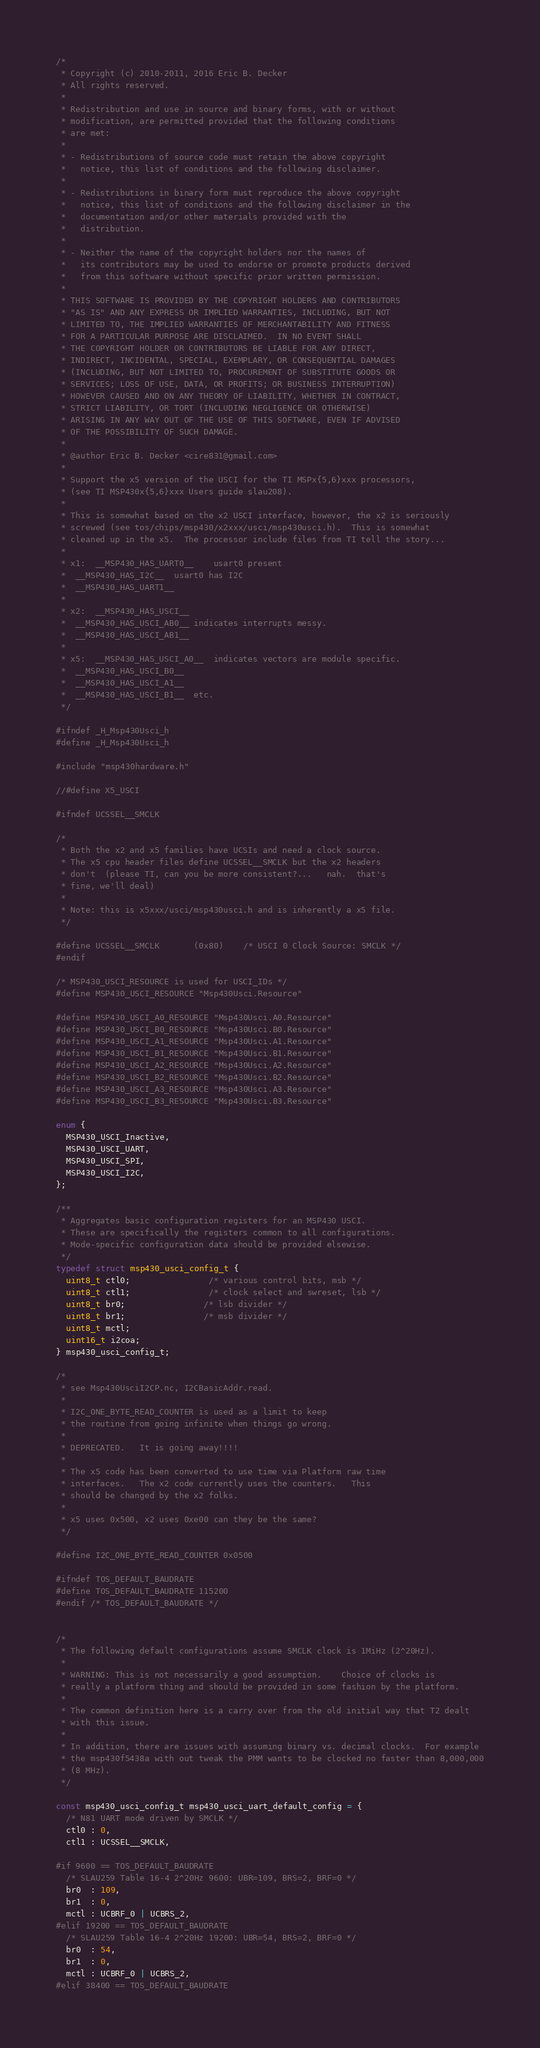<code> <loc_0><loc_0><loc_500><loc_500><_C_>/*
 * Copyright (c) 2010-2011, 2016 Eric B. Decker
 * All rights reserved.
 *
 * Redistribution and use in source and binary forms, with or without
 * modification, are permitted provided that the following conditions
 * are met:
 *
 * - Redistributions of source code must retain the above copyright
 *   notice, this list of conditions and the following disclaimer.
 *
 * - Redistributions in binary form must reproduce the above copyright
 *   notice, this list of conditions and the following disclaimer in the
 *   documentation and/or other materials provided with the
 *   distribution.
 *
 * - Neither the name of the copyright holders nor the names of
 *   its contributors may be used to endorse or promote products derived
 *   from this software without specific prior written permission.
 *
 * THIS SOFTWARE IS PROVIDED BY THE COPYRIGHT HOLDERS AND CONTRIBUTORS
 * "AS IS" AND ANY EXPRESS OR IMPLIED WARRANTIES, INCLUDING, BUT NOT
 * LIMITED TO, THE IMPLIED WARRANTIES OF MERCHANTABILITY AND FITNESS
 * FOR A PARTICULAR PURPOSE ARE DISCLAIMED.  IN NO EVENT SHALL
 * THE COPYRIGHT HOLDER OR CONTRIBUTORS BE LIABLE FOR ANY DIRECT,
 * INDIRECT, INCIDENTAL, SPECIAL, EXEMPLARY, OR CONSEQUENTIAL DAMAGES
 * (INCLUDING, BUT NOT LIMITED TO, PROCUREMENT OF SUBSTITUTE GOODS OR
 * SERVICES; LOSS OF USE, DATA, OR PROFITS; OR BUSINESS INTERRUPTION)
 * HOWEVER CAUSED AND ON ANY THEORY OF LIABILITY, WHETHER IN CONTRACT,
 * STRICT LIABILITY, OR TORT (INCLUDING NEGLIGENCE OR OTHERWISE)
 * ARISING IN ANY WAY OUT OF THE USE OF THIS SOFTWARE, EVEN IF ADVISED
 * OF THE POSSIBILITY OF SUCH DAMAGE.
 *
 * @author Eric B. Decker <cire831@gmail.com>
 *
 * Support the x5 version of the USCI for the TI MSPx{5,6}xxx processors,
 * (see TI MSP430x{5,6}xxx Users guide slau208).
 *
 * This is somewhat based on the x2 USCI interface, however, the x2 is seriously
 * screwed (see tos/chips/msp430/x2xxx/usci/msp430usci.h).  This is somewhat
 * cleaned up in the x5.  The processor include files from TI tell the story...
 *
 * x1:  __MSP430_HAS_UART0__	usart0 present
 *	__MSP430_HAS_I2C__	usart0 has I2C
 *	__MSP430_HAS_UART1__
 *
 * x2:	__MSP430_HAS_USCI__
 *	__MSP430_HAS_USCI_AB0__	indicates interrupts messy.
 *	__MSP430_HAS_USCI_AB1__
 *
 * x5:	__MSP430_HAS_USCI_A0__	indicates vectors are module specific.
 *	__MSP430_HAS_USCI_B0__
 *	__MSP430_HAS_USCI_A1__
 *	__MSP430_HAS_USCI_B1__	etc.
 */

#ifndef _H_Msp430Usci_h
#define _H_Msp430Usci_h

#include "msp430hardware.h"

//#define X5_USCI

#ifndef UCSSEL__SMCLK

/*
 * Both the x2 and x5 families have UCSIs and need a clock source.
 * The x5 cpu header files define UCSSEL__SMCLK but the x2 headers
 * don't  (please TI, can you be more consistent?...   nah.  that's
 * fine, we'll deal)
 *
 * Note: this is x5xxx/usci/msp430usci.h and is inherently a x5 file.
 */

#define UCSSEL__SMCLK       (0x80)    /* USCI 0 Clock Source: SMCLK */
#endif

/* MSP430_USCI_RESOURCE is used for USCI_IDs */
#define MSP430_USCI_RESOURCE "Msp430Usci.Resource"

#define MSP430_USCI_A0_RESOURCE "Msp430Usci.A0.Resource"
#define MSP430_USCI_B0_RESOURCE "Msp430Usci.B0.Resource"
#define MSP430_USCI_A1_RESOURCE "Msp430Usci.A1.Resource"
#define MSP430_USCI_B1_RESOURCE "Msp430Usci.B1.Resource"
#define MSP430_USCI_A2_RESOURCE "Msp430Usci.A2.Resource"
#define MSP430_USCI_B2_RESOURCE "Msp430Usci.B2.Resource"
#define MSP430_USCI_A3_RESOURCE "Msp430Usci.A3.Resource"
#define MSP430_USCI_B3_RESOURCE "Msp430Usci.B3.Resource"

enum {
  MSP430_USCI_Inactive,
  MSP430_USCI_UART,
  MSP430_USCI_SPI,
  MSP430_USCI_I2C,
};

/**
 * Aggregates basic configuration registers for an MSP430 USCI.
 * These are specifically the registers common to all configurations.
 * Mode-specific configuration data should be provided elsewise.
 */
typedef struct msp430_usci_config_t {
  uint8_t ctl0;				/* various control bits, msb */
  uint8_t ctl1;				/* clock select and swreset, lsb */
  uint8_t br0;				/* lsb divider */
  uint8_t br1;				/* msb divider */
  uint8_t mctl;
  uint16_t i2coa;
} msp430_usci_config_t;

/*
 * see Msp430UsciI2CP.nc, I2CBasicAddr.read.
 *
 * I2C_ONE_BYTE_READ_COUNTER is used as a limit to keep
 * the routine from going infinite when things go wrong.
 *
 * DEPRECATED.   It is going away!!!!
 *
 * The x5 code has been converted to use time via Platform raw time
 * interfaces.   The x2 code currently uses the counters.   This
 * should be changed by the x2 folks.
 *
 * x5 uses 0x500, x2 uses 0xe00 can they be the same?
 */

#define I2C_ONE_BYTE_READ_COUNTER 0x0500

#ifndef TOS_DEFAULT_BAUDRATE
#define TOS_DEFAULT_BAUDRATE 115200
#endif /* TOS_DEFAULT_BAUDRATE */


/*
 * The following default configurations assume SMCLK clock is 1MiHz (2^20Hz).
 *
 * WARNING: This is not necessarily a good assumption.    Choice of clocks is
 * really a platform thing and should be provided in some fashion by the platform.
 *
 * The common definition here is a carry over from the old initial way that T2 dealt
 * with this issue.
 *
 * In addition, there are issues with assuming binary vs. decimal clocks.  For example
 * the msp430f5438a with out tweak the PMM wants to be clocked no faster than 8,000,000
 * (8 MHz).
 */

const msp430_usci_config_t msp430_usci_uart_default_config = {
  /* N81 UART mode driven by SMCLK */
  ctl0 : 0,
  ctl1 : UCSSEL__SMCLK,

#if 9600 == TOS_DEFAULT_BAUDRATE
  /* SLAU259 Table 16-4 2^20Hz 9600: UBR=109, BRS=2, BRF=0 */
  br0  : 109,
  br1  : 0,
  mctl : UCBRF_0 | UCBRS_2,
#elif 19200 == TOS_DEFAULT_BAUDRATE
  /* SLAU259 Table 16-4 2^20Hz 19200: UBR=54, BRS=2, BRF=0 */
  br0  : 54,
  br1  : 0,
  mctl : UCBRF_0 | UCBRS_2,
#elif 38400 == TOS_DEFAULT_BAUDRATE</code> 